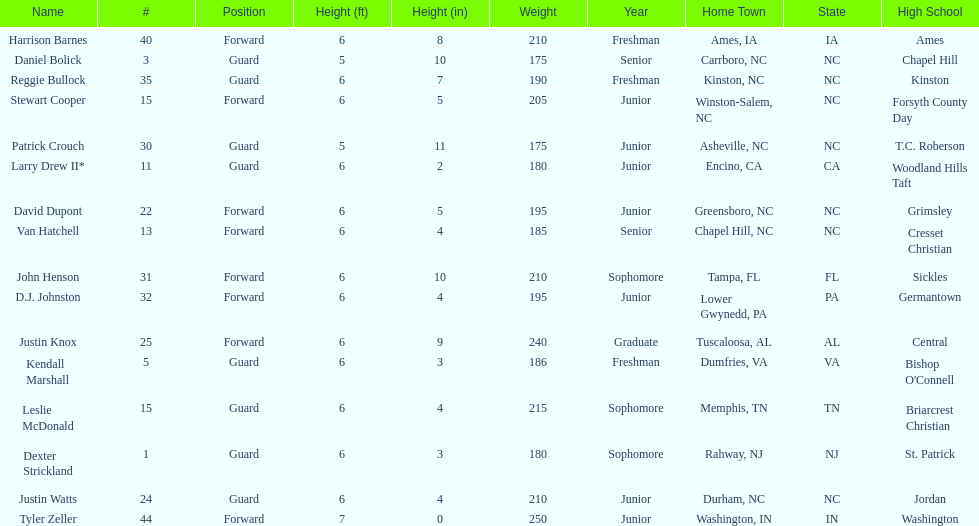Parse the full table. {'header': ['Name', '#', 'Position', 'Height (ft)', 'Height (in)', 'Weight', 'Year', 'Home Town', 'State', 'High School'], 'rows': [['Harrison Barnes', '40', 'Forward', '6', '8', '210', 'Freshman', 'Ames, IA', 'IA', 'Ames'], ['Daniel Bolick', '3', 'Guard', '5', '10', '175', 'Senior', 'Carrboro, NC', 'NC', 'Chapel Hill'], ['Reggie Bullock', '35', 'Guard', '6', '7', '190', 'Freshman', 'Kinston, NC', 'NC', 'Kinston'], ['Stewart Cooper', '15', 'Forward', '6', '5', '205', 'Junior', 'Winston-Salem, NC', 'NC', 'Forsyth County Day'], ['Patrick Crouch', '30', 'Guard', '5', '11', '175', 'Junior', 'Asheville, NC', 'NC', 'T.C. Roberson'], ['Larry Drew II*', '11', 'Guard', '6', '2', '180', 'Junior', 'Encino, CA', 'CA', 'Woodland Hills Taft'], ['David Dupont', '22', 'Forward', '6', '5', '195', 'Junior', 'Greensboro, NC', 'NC', 'Grimsley'], ['Van Hatchell', '13', 'Forward', '6', '4', '185', 'Senior', 'Chapel Hill, NC', 'NC', 'Cresset Christian'], ['John Henson', '31', 'Forward', '6', '10', '210', 'Sophomore', 'Tampa, FL', 'FL', 'Sickles'], ['D.J. Johnston', '32', 'Forward', '6', '4', '195', 'Junior', 'Lower Gwynedd, PA', 'PA', 'Germantown'], ['Justin Knox', '25', 'Forward', '6', '9', '240', 'Graduate', 'Tuscaloosa, AL', 'AL', 'Central'], ['Kendall Marshall', '5', 'Guard', '6', '3', '186', 'Freshman', 'Dumfries, VA', 'VA', "Bishop O'Connell"], ['Leslie McDonald', '15', 'Guard', '6', '4', '215', 'Sophomore', 'Memphis, TN', 'TN', 'Briarcrest Christian'], ['Dexter Strickland', '1', 'Guard', '6', '3', '180', 'Sophomore', 'Rahway, NJ', 'NJ', 'St. Patrick'], ['Justin Watts', '24', 'Guard', '6', '4', '210', 'Junior', 'Durham, NC', 'NC', 'Jordan'], ['Tyler Zeller', '44', 'Forward', '7', '0', '250', 'Junior', 'Washington, IN', 'IN', 'Washington']]} Total number of players whose home town was in north carolina (nc) 7. 